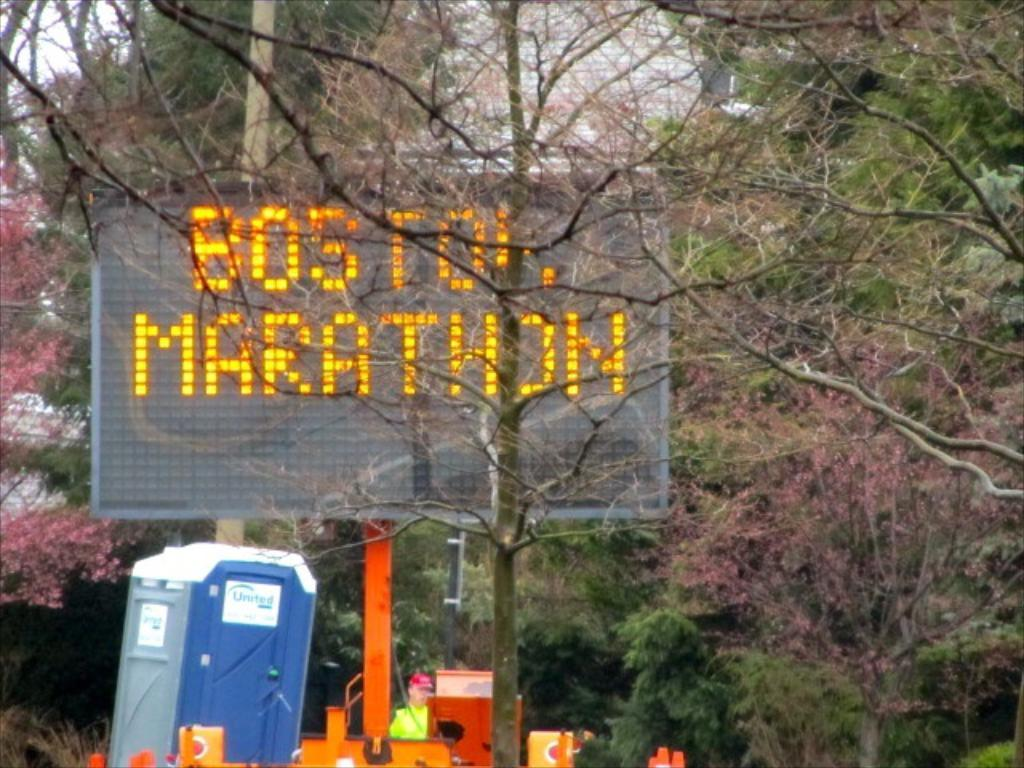<image>
Give a short and clear explanation of the subsequent image. An orange construction sign says Boston Marathon and a blue portable toilet is below it. 